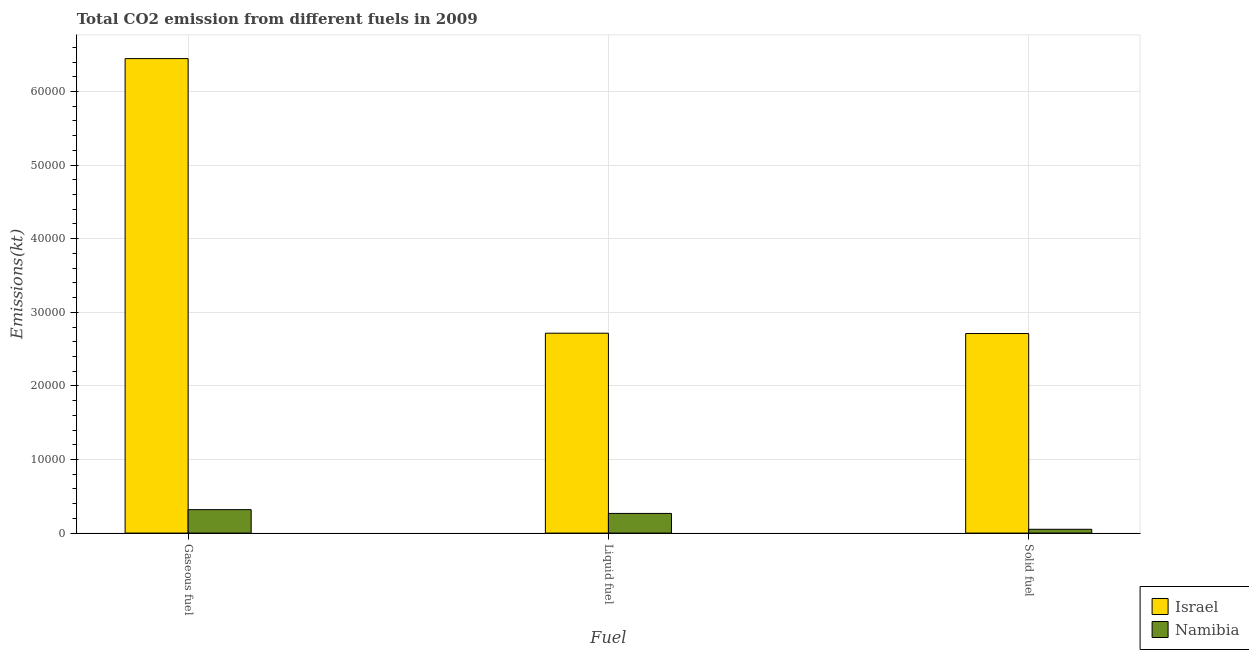How many groups of bars are there?
Your answer should be very brief. 3. Are the number of bars per tick equal to the number of legend labels?
Provide a succinct answer. Yes. Are the number of bars on each tick of the X-axis equal?
Provide a succinct answer. Yes. What is the label of the 2nd group of bars from the left?
Keep it short and to the point. Liquid fuel. What is the amount of co2 emissions from gaseous fuel in Namibia?
Offer a very short reply. 3182.96. Across all countries, what is the maximum amount of co2 emissions from gaseous fuel?
Keep it short and to the point. 6.45e+04. Across all countries, what is the minimum amount of co2 emissions from liquid fuel?
Give a very brief answer. 2669.58. In which country was the amount of co2 emissions from liquid fuel maximum?
Offer a very short reply. Israel. In which country was the amount of co2 emissions from gaseous fuel minimum?
Keep it short and to the point. Namibia. What is the total amount of co2 emissions from gaseous fuel in the graph?
Your answer should be very brief. 6.77e+04. What is the difference between the amount of co2 emissions from solid fuel in Namibia and that in Israel?
Make the answer very short. -2.66e+04. What is the difference between the amount of co2 emissions from solid fuel in Namibia and the amount of co2 emissions from gaseous fuel in Israel?
Offer a very short reply. -6.40e+04. What is the average amount of co2 emissions from liquid fuel per country?
Ensure brevity in your answer.  1.49e+04. What is the difference between the amount of co2 emissions from solid fuel and amount of co2 emissions from liquid fuel in Namibia?
Keep it short and to the point. -2156.2. In how many countries, is the amount of co2 emissions from gaseous fuel greater than 4000 kt?
Your answer should be compact. 1. What is the ratio of the amount of co2 emissions from solid fuel in Israel to that in Namibia?
Provide a succinct answer. 52.81. What is the difference between the highest and the second highest amount of co2 emissions from liquid fuel?
Offer a terse response. 2.45e+04. What is the difference between the highest and the lowest amount of co2 emissions from solid fuel?
Your response must be concise. 2.66e+04. In how many countries, is the amount of co2 emissions from liquid fuel greater than the average amount of co2 emissions from liquid fuel taken over all countries?
Your answer should be very brief. 1. What does the 1st bar from the left in Gaseous fuel represents?
Make the answer very short. Israel. What does the 1st bar from the right in Liquid fuel represents?
Keep it short and to the point. Namibia. Is it the case that in every country, the sum of the amount of co2 emissions from gaseous fuel and amount of co2 emissions from liquid fuel is greater than the amount of co2 emissions from solid fuel?
Your answer should be very brief. Yes. How many countries are there in the graph?
Give a very brief answer. 2. Are the values on the major ticks of Y-axis written in scientific E-notation?
Provide a short and direct response. No. Where does the legend appear in the graph?
Keep it short and to the point. Bottom right. What is the title of the graph?
Your answer should be very brief. Total CO2 emission from different fuels in 2009. What is the label or title of the X-axis?
Your answer should be compact. Fuel. What is the label or title of the Y-axis?
Your response must be concise. Emissions(kt). What is the Emissions(kt) of Israel in Gaseous fuel?
Your answer should be very brief. 6.45e+04. What is the Emissions(kt) of Namibia in Gaseous fuel?
Give a very brief answer. 3182.96. What is the Emissions(kt) of Israel in Liquid fuel?
Your response must be concise. 2.72e+04. What is the Emissions(kt) in Namibia in Liquid fuel?
Provide a short and direct response. 2669.58. What is the Emissions(kt) in Israel in Solid fuel?
Keep it short and to the point. 2.71e+04. What is the Emissions(kt) in Namibia in Solid fuel?
Ensure brevity in your answer.  513.38. Across all Fuel, what is the maximum Emissions(kt) in Israel?
Offer a terse response. 6.45e+04. Across all Fuel, what is the maximum Emissions(kt) of Namibia?
Ensure brevity in your answer.  3182.96. Across all Fuel, what is the minimum Emissions(kt) of Israel?
Your answer should be compact. 2.71e+04. Across all Fuel, what is the minimum Emissions(kt) in Namibia?
Ensure brevity in your answer.  513.38. What is the total Emissions(kt) in Israel in the graph?
Provide a succinct answer. 1.19e+05. What is the total Emissions(kt) in Namibia in the graph?
Ensure brevity in your answer.  6365.91. What is the difference between the Emissions(kt) in Israel in Gaseous fuel and that in Liquid fuel?
Provide a succinct answer. 3.73e+04. What is the difference between the Emissions(kt) of Namibia in Gaseous fuel and that in Liquid fuel?
Offer a terse response. 513.38. What is the difference between the Emissions(kt) of Israel in Gaseous fuel and that in Solid fuel?
Keep it short and to the point. 3.74e+04. What is the difference between the Emissions(kt) in Namibia in Gaseous fuel and that in Solid fuel?
Make the answer very short. 2669.58. What is the difference between the Emissions(kt) of Israel in Liquid fuel and that in Solid fuel?
Provide a short and direct response. 44. What is the difference between the Emissions(kt) of Namibia in Liquid fuel and that in Solid fuel?
Your answer should be very brief. 2156.2. What is the difference between the Emissions(kt) in Israel in Gaseous fuel and the Emissions(kt) in Namibia in Liquid fuel?
Keep it short and to the point. 6.18e+04. What is the difference between the Emissions(kt) in Israel in Gaseous fuel and the Emissions(kt) in Namibia in Solid fuel?
Your response must be concise. 6.40e+04. What is the difference between the Emissions(kt) in Israel in Liquid fuel and the Emissions(kt) in Namibia in Solid fuel?
Provide a succinct answer. 2.66e+04. What is the average Emissions(kt) of Israel per Fuel?
Ensure brevity in your answer.  3.96e+04. What is the average Emissions(kt) in Namibia per Fuel?
Your answer should be very brief. 2121.97. What is the difference between the Emissions(kt) of Israel and Emissions(kt) of Namibia in Gaseous fuel?
Your response must be concise. 6.13e+04. What is the difference between the Emissions(kt) in Israel and Emissions(kt) in Namibia in Liquid fuel?
Ensure brevity in your answer.  2.45e+04. What is the difference between the Emissions(kt) in Israel and Emissions(kt) in Namibia in Solid fuel?
Give a very brief answer. 2.66e+04. What is the ratio of the Emissions(kt) of Israel in Gaseous fuel to that in Liquid fuel?
Give a very brief answer. 2.37. What is the ratio of the Emissions(kt) in Namibia in Gaseous fuel to that in Liquid fuel?
Give a very brief answer. 1.19. What is the ratio of the Emissions(kt) of Israel in Gaseous fuel to that in Solid fuel?
Provide a short and direct response. 2.38. What is the ratio of the Emissions(kt) of Namibia in Gaseous fuel to that in Solid fuel?
Give a very brief answer. 6.2. What is the ratio of the Emissions(kt) in Israel in Liquid fuel to that in Solid fuel?
Offer a terse response. 1. What is the difference between the highest and the second highest Emissions(kt) in Israel?
Offer a very short reply. 3.73e+04. What is the difference between the highest and the second highest Emissions(kt) of Namibia?
Your answer should be compact. 513.38. What is the difference between the highest and the lowest Emissions(kt) of Israel?
Provide a short and direct response. 3.74e+04. What is the difference between the highest and the lowest Emissions(kt) in Namibia?
Keep it short and to the point. 2669.58. 